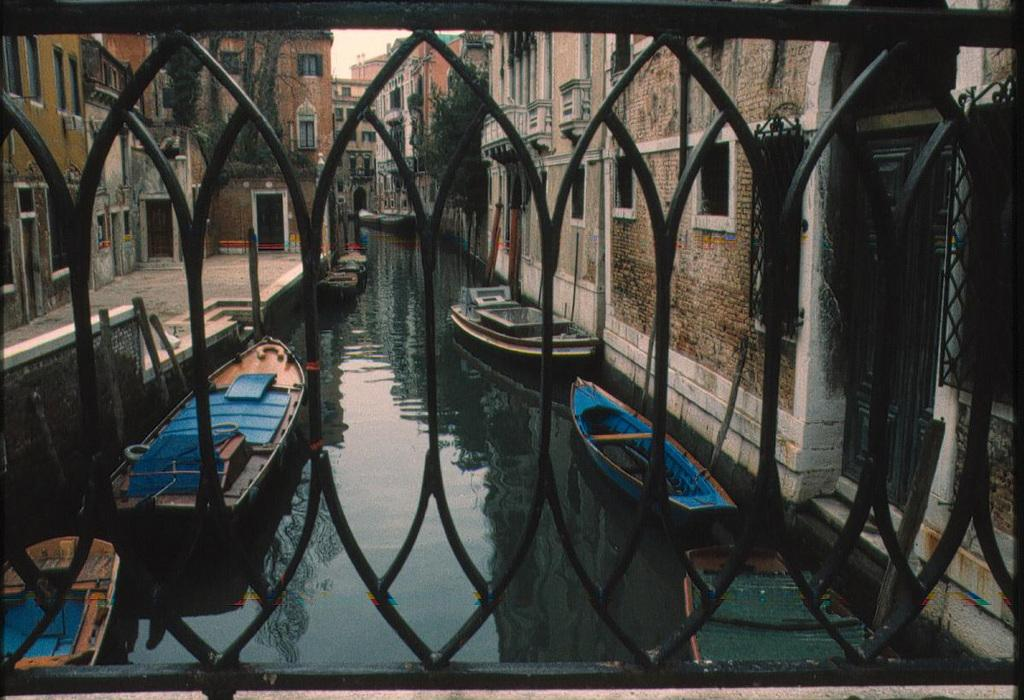What body of water is present in the image? There is a lake in the image. What is floating on the water in the lake? There are boats floating on the water in the lake. What type of structure can be seen in the image? There is black color railing visible in the image. What can be seen on either side of the lake? There are buildings on either side of the lake. What type of caption is written on the bottom of the image? There is no caption written on the bottom of the image. 